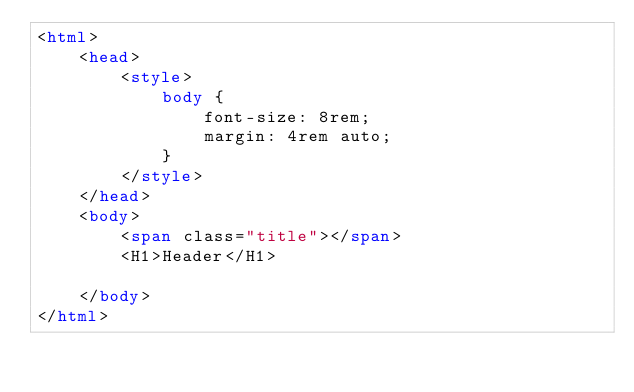<code> <loc_0><loc_0><loc_500><loc_500><_HTML_><html>
    <head>
        <style>
            body {
                font-size: 8rem;
                margin: 4rem auto;
            }
        </style>
    </head>
    <body>
        <span class="title"></span>
        <H1>Header</H1>

    </body>
</html></code> 